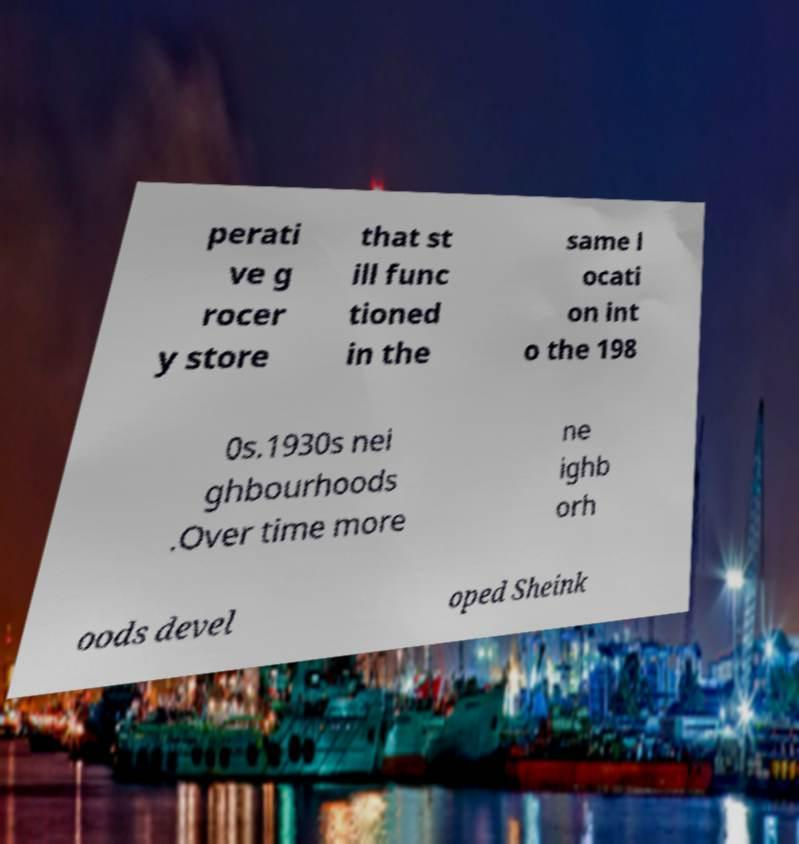There's text embedded in this image that I need extracted. Can you transcribe it verbatim? perati ve g rocer y store that st ill func tioned in the same l ocati on int o the 198 0s.1930s nei ghbourhoods .Over time more ne ighb orh oods devel oped Sheink 